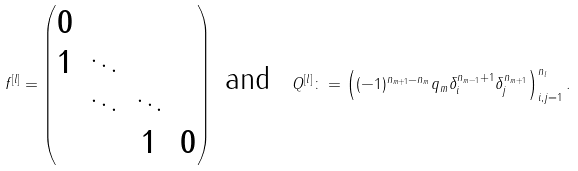<formula> <loc_0><loc_0><loc_500><loc_500>f ^ { [ l ] } = \begin{pmatrix} 0 & & & \\ 1 & \ddots & & \\ & \ddots & \ddots & \\ & & 1 & 0 \\ \end{pmatrix} \ \text {and} \ \ Q ^ { [ l ] } \colon = \left ( ( - 1 ) ^ { n _ { m + 1 } - n _ { m } } q _ { m } \delta _ { i } ^ { n _ { m - 1 } + 1 } \delta _ { j } ^ { n _ { m + 1 } } \right ) _ { i , j = 1 } ^ { n _ { l } } .</formula> 